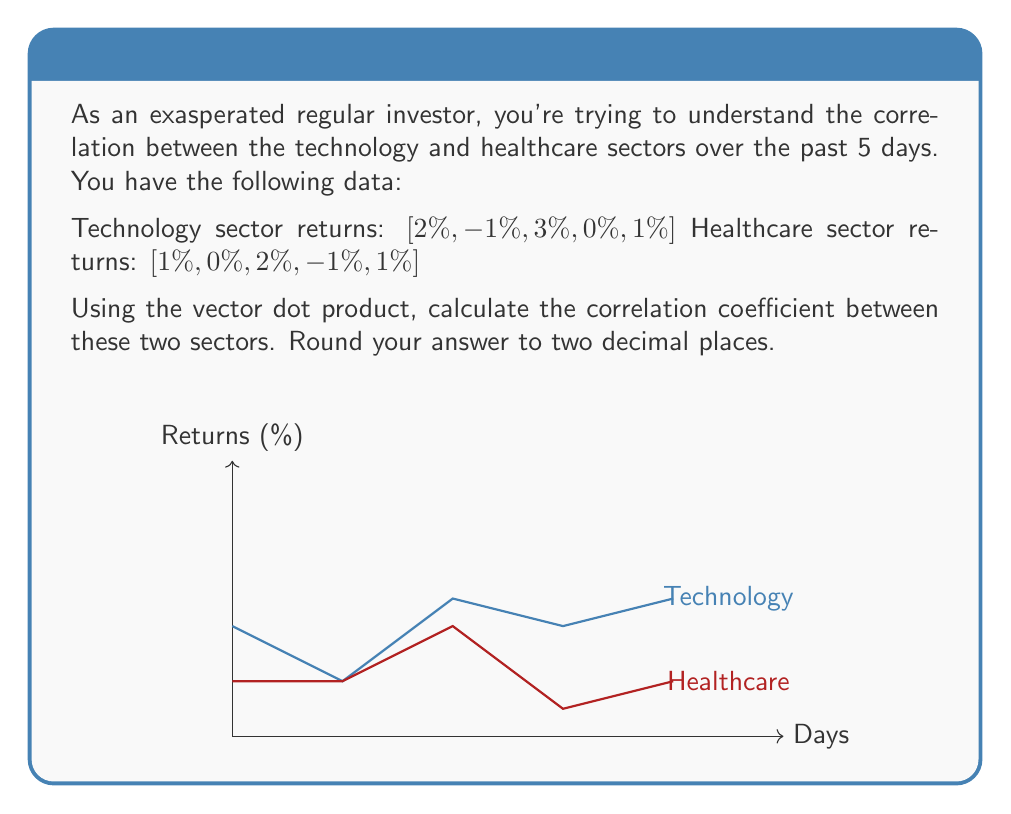What is the answer to this math problem? To calculate the correlation coefficient using vector dot product, we'll follow these steps:

1) First, we need to center the data by subtracting the mean from each value.

   For Technology: 
   Mean = $(2 + (-1) + 3 + 0 + 1) / 5 = 1$
   Centered vector: $\mathbf{a} = [1, -2, 2, -1, 0]$

   For Healthcare:
   Mean = $(1 + 0 + 2 + (-1) + 1) / 5 = 0.6$
   Centered vector: $\mathbf{b} = [0.4, -0.6, 1.4, -1.6, 0.4]$

2) Calculate the dot product of these centered vectors:
   $$\mathbf{a} \cdot \mathbf{b} = (1)(0.4) + (-2)(-0.6) + (2)(1.4) + (-1)(-1.6) + (0)(0.4) = 5.2$$

3) Calculate the magnitudes of the vectors:
   $$|\mathbf{a}| = \sqrt{1^2 + (-2)^2 + 2^2 + (-1)^2 + 0^2} = \sqrt{10} = 3.16$$
   $$|\mathbf{b}| = \sqrt{0.4^2 + (-0.6)^2 + 1.4^2 + (-1.6)^2 + 0.4^2} = \sqrt{4.12} = 2.03$$

4) The correlation coefficient is the dot product divided by the product of the magnitudes:
   $$r = \frac{\mathbf{a} \cdot \mathbf{b}}{|\mathbf{a}||\mathbf{b}|} = \frac{5.2}{(3.16)(2.03)} = 0.8115$$

5) Rounding to two decimal places: 0.81
Answer: 0.81 